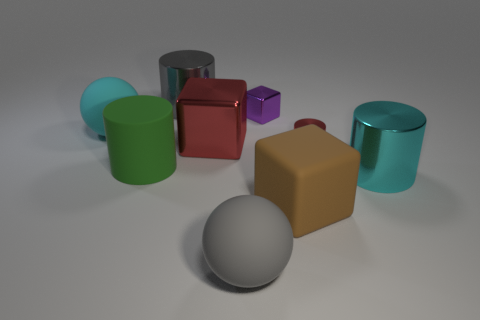Subtract all blue cylinders. Subtract all blue cubes. How many cylinders are left? 4 Subtract all cylinders. How many objects are left? 5 Subtract 1 brown cubes. How many objects are left? 8 Subtract all tiny objects. Subtract all big brown blocks. How many objects are left? 6 Add 5 big metallic cylinders. How many big metallic cylinders are left? 7 Add 3 cyan balls. How many cyan balls exist? 4 